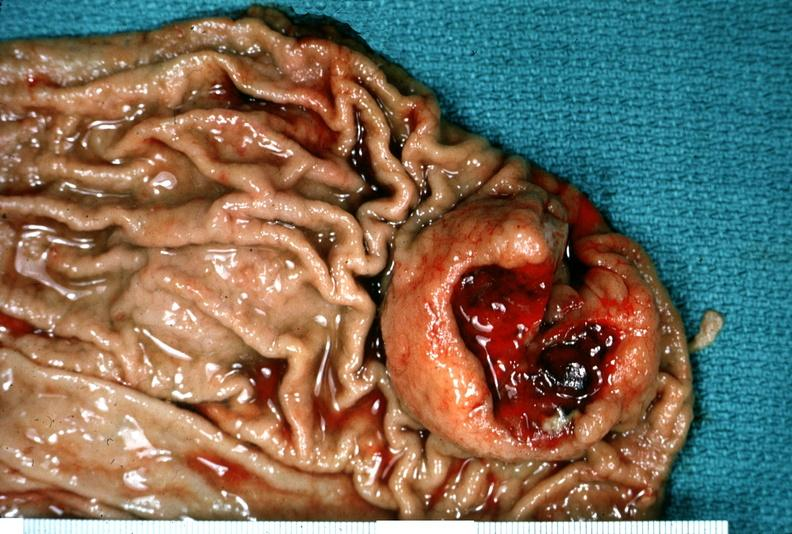what is present?
Answer the question using a single word or phrase. Gastrointestinal 